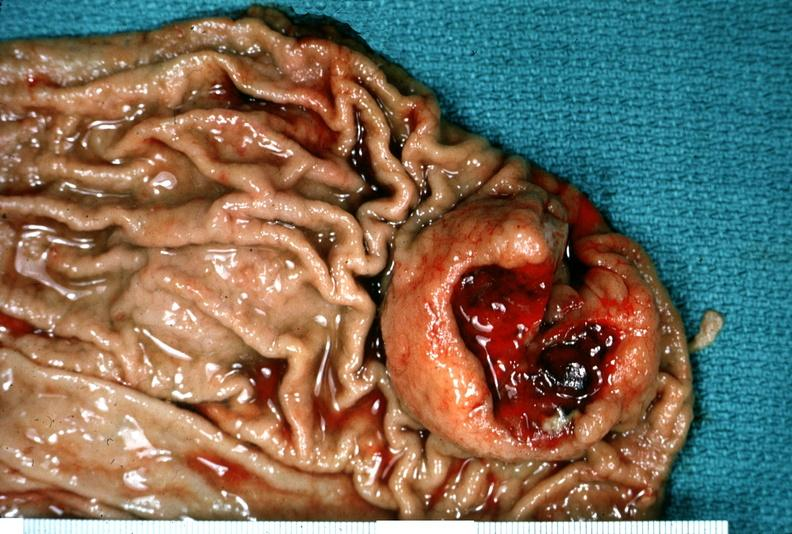what is present?
Answer the question using a single word or phrase. Gastrointestinal 